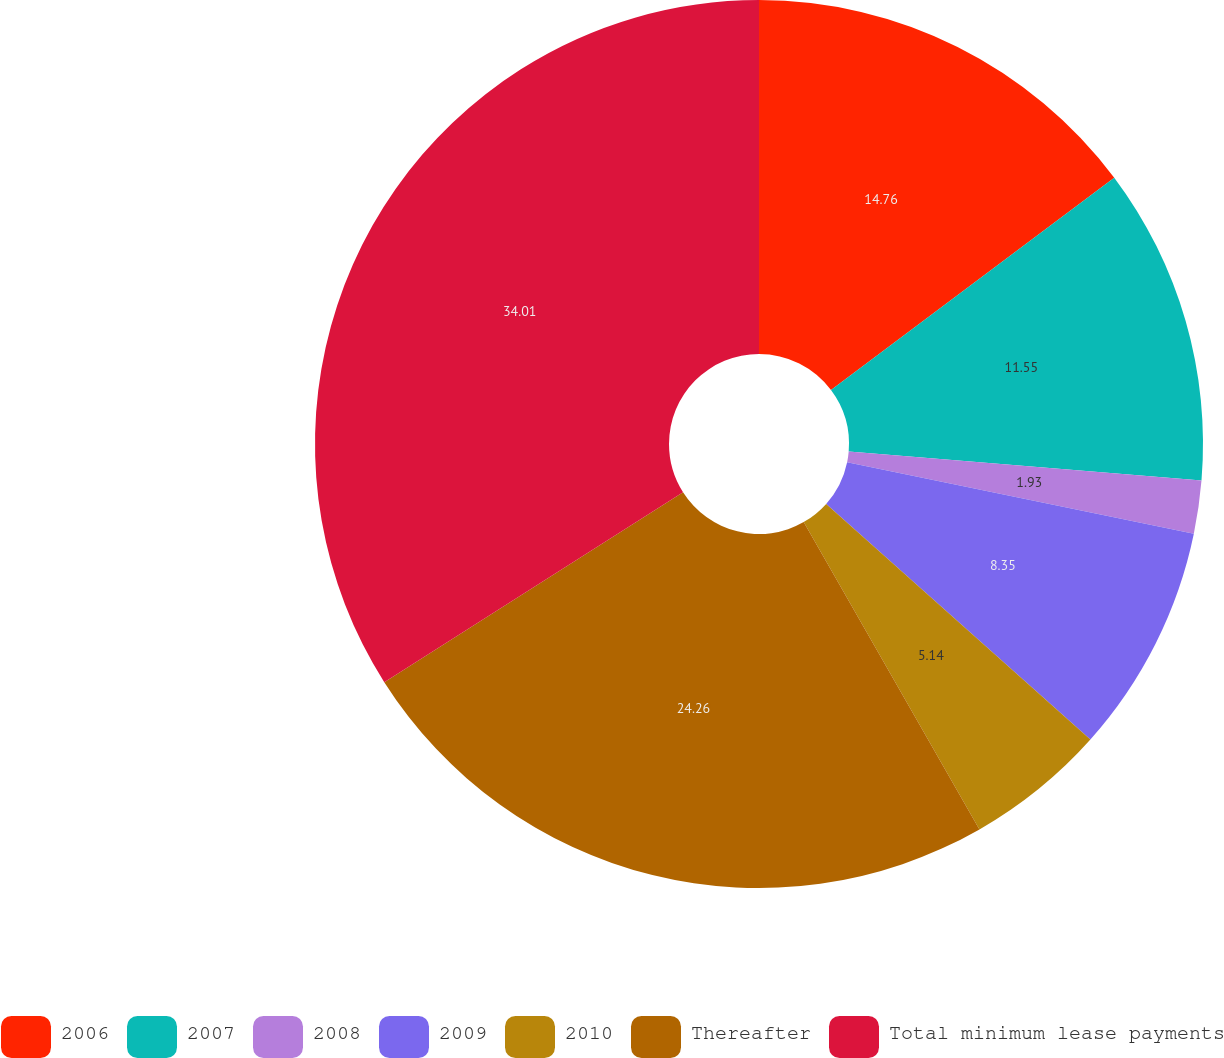Convert chart. <chart><loc_0><loc_0><loc_500><loc_500><pie_chart><fcel>2006<fcel>2007<fcel>2008<fcel>2009<fcel>2010<fcel>Thereafter<fcel>Total minimum lease payments<nl><fcel>14.76%<fcel>11.55%<fcel>1.93%<fcel>8.35%<fcel>5.14%<fcel>24.26%<fcel>34.01%<nl></chart> 